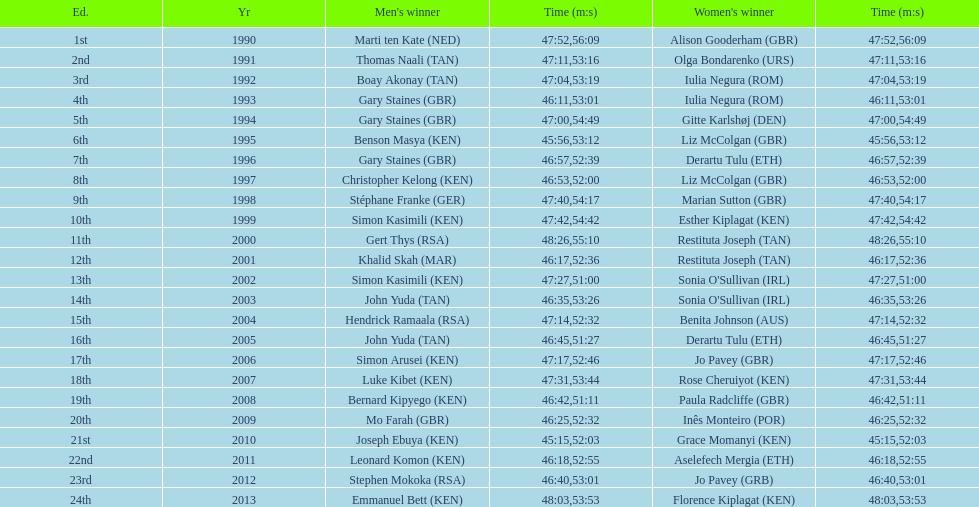How many men winners had times at least 46 minutes or under? 2. 